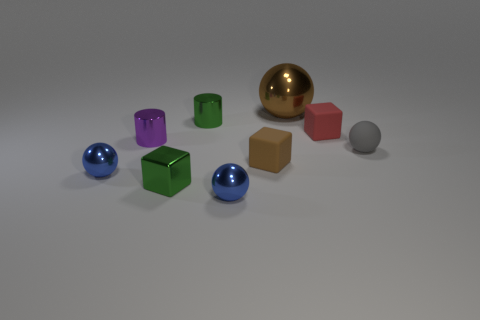Subtract all red cylinders. How many blue balls are left? 2 Add 1 small cubes. How many objects exist? 10 Subtract all small red matte cubes. How many cubes are left? 2 Subtract all cylinders. How many objects are left? 7 Subtract all gray spheres. How many spheres are left? 3 Subtract 2 spheres. How many spheres are left? 2 Subtract all cyan balls. Subtract all blue blocks. How many balls are left? 4 Subtract all small red matte cylinders. Subtract all red things. How many objects are left? 8 Add 3 blue balls. How many blue balls are left? 5 Add 3 brown things. How many brown things exist? 5 